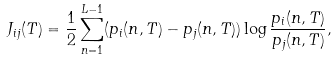Convert formula to latex. <formula><loc_0><loc_0><loc_500><loc_500>J _ { i j } ( T ) = \frac { 1 } { 2 } \sum _ { n = 1 } ^ { L - 1 } ( p _ { i } ( n , T ) - p _ { j } ( n , T ) ) \log \frac { p _ { i } ( n , T ) } { p _ { j } ( n , T ) } ,</formula> 